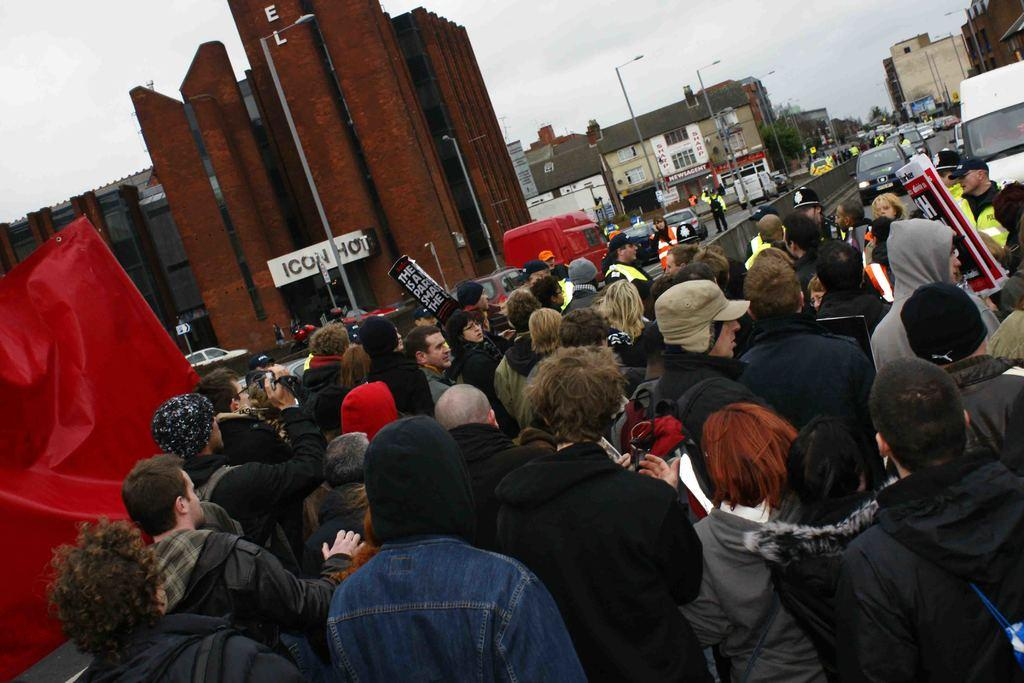How many people can be seen in the image? There are people in the image, but the exact number is not specified. What type of lighting is present in the image? There are street lights in the image. What type of structures are visible in the image? There are buildings in the image. What type of transportation is present in the image? There are vehicles and cars in the image. What type of signage is present in the image? There are posters in the image. What type of vegetation is visible in the image? There are trees in the image. What type of surface can be seen in the image? There is a road in the image. What type of natural elements are visible in the image? There are clouds visible in the image. What type of sky is visible in the image? The sky is visible in the image. What type of balls are being used to lead the force in the image? There are no balls, leading, or force present in the image. 